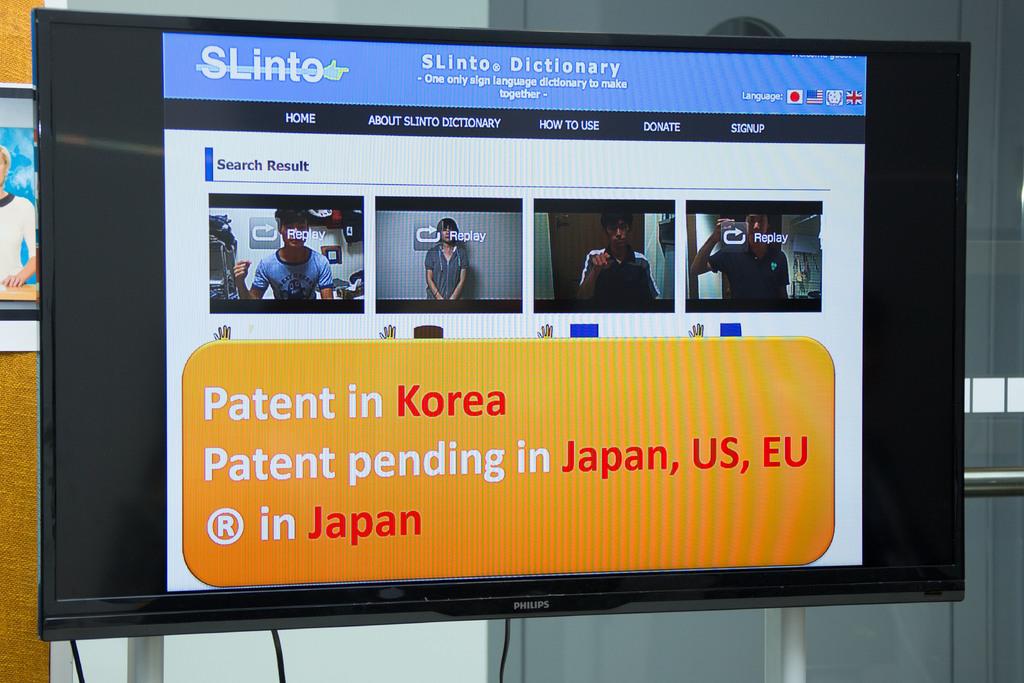Where is the patent already obtained?
Your answer should be compact. Korea. What doesthe company slinto do?
Keep it short and to the point. Dictionary. 